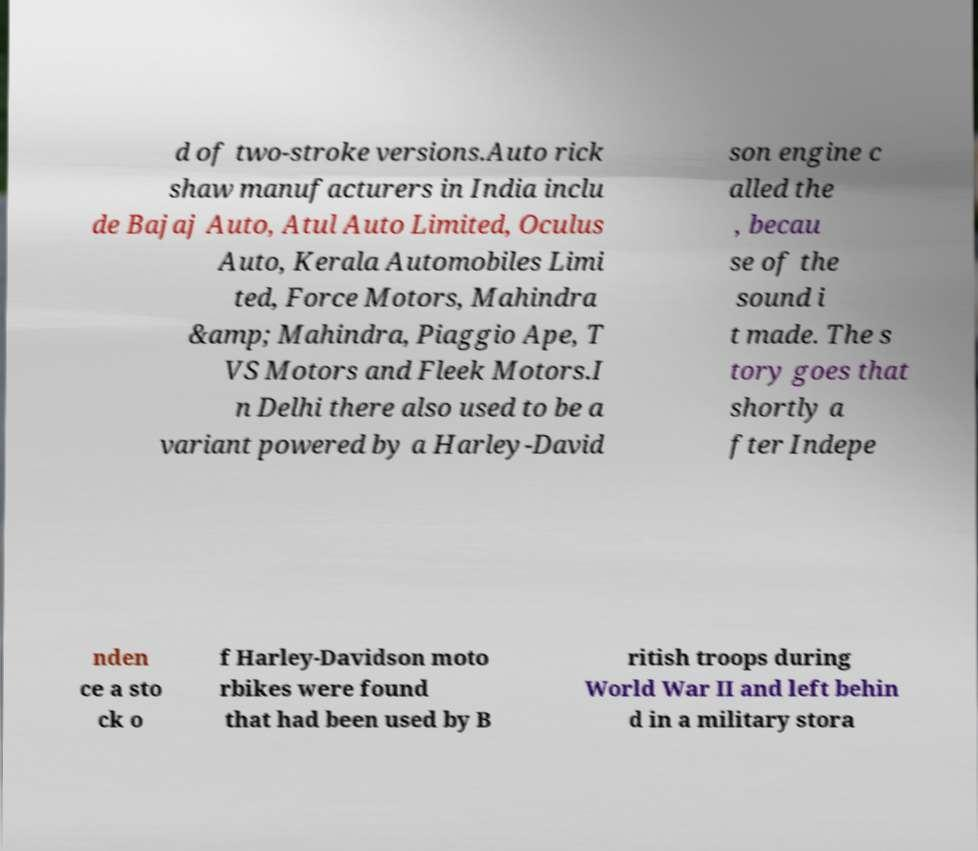Please read and relay the text visible in this image. What does it say? d of two-stroke versions.Auto rick shaw manufacturers in India inclu de Bajaj Auto, Atul Auto Limited, Oculus Auto, Kerala Automobiles Limi ted, Force Motors, Mahindra &amp; Mahindra, Piaggio Ape, T VS Motors and Fleek Motors.I n Delhi there also used to be a variant powered by a Harley-David son engine c alled the , becau se of the sound i t made. The s tory goes that shortly a fter Indepe nden ce a sto ck o f Harley-Davidson moto rbikes were found that had been used by B ritish troops during World War II and left behin d in a military stora 